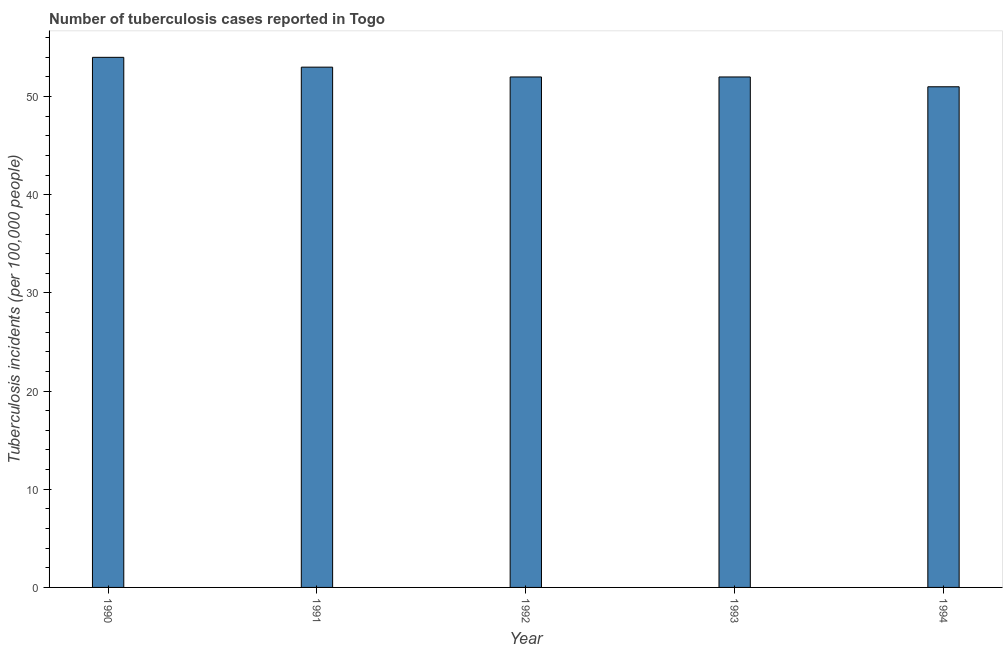Does the graph contain any zero values?
Provide a succinct answer. No. Does the graph contain grids?
Your response must be concise. No. What is the title of the graph?
Provide a succinct answer. Number of tuberculosis cases reported in Togo. What is the label or title of the Y-axis?
Your response must be concise. Tuberculosis incidents (per 100,0 people). What is the number of tuberculosis incidents in 1992?
Offer a very short reply. 52. Across all years, what is the minimum number of tuberculosis incidents?
Make the answer very short. 51. In which year was the number of tuberculosis incidents maximum?
Give a very brief answer. 1990. In which year was the number of tuberculosis incidents minimum?
Keep it short and to the point. 1994. What is the sum of the number of tuberculosis incidents?
Provide a short and direct response. 262. What is the average number of tuberculosis incidents per year?
Your answer should be compact. 52. In how many years, is the number of tuberculosis incidents greater than 22 ?
Your answer should be very brief. 5. What is the ratio of the number of tuberculosis incidents in 1990 to that in 1992?
Make the answer very short. 1.04. What is the difference between the highest and the lowest number of tuberculosis incidents?
Give a very brief answer. 3. In how many years, is the number of tuberculosis incidents greater than the average number of tuberculosis incidents taken over all years?
Give a very brief answer. 2. How many bars are there?
Offer a very short reply. 5. How many years are there in the graph?
Your answer should be very brief. 5. Are the values on the major ticks of Y-axis written in scientific E-notation?
Your answer should be very brief. No. What is the Tuberculosis incidents (per 100,000 people) in 1991?
Offer a terse response. 53. What is the difference between the Tuberculosis incidents (per 100,000 people) in 1990 and 1991?
Provide a succinct answer. 1. What is the difference between the Tuberculosis incidents (per 100,000 people) in 1990 and 1994?
Offer a very short reply. 3. What is the difference between the Tuberculosis incidents (per 100,000 people) in 1991 and 1992?
Your answer should be very brief. 1. What is the difference between the Tuberculosis incidents (per 100,000 people) in 1991 and 1993?
Your answer should be very brief. 1. What is the difference between the Tuberculosis incidents (per 100,000 people) in 1991 and 1994?
Give a very brief answer. 2. What is the difference between the Tuberculosis incidents (per 100,000 people) in 1992 and 1994?
Offer a very short reply. 1. What is the ratio of the Tuberculosis incidents (per 100,000 people) in 1990 to that in 1991?
Provide a succinct answer. 1.02. What is the ratio of the Tuberculosis incidents (per 100,000 people) in 1990 to that in 1992?
Make the answer very short. 1.04. What is the ratio of the Tuberculosis incidents (per 100,000 people) in 1990 to that in 1993?
Your answer should be compact. 1.04. What is the ratio of the Tuberculosis incidents (per 100,000 people) in 1990 to that in 1994?
Ensure brevity in your answer.  1.06. What is the ratio of the Tuberculosis incidents (per 100,000 people) in 1991 to that in 1994?
Offer a very short reply. 1.04. What is the ratio of the Tuberculosis incidents (per 100,000 people) in 1992 to that in 1994?
Keep it short and to the point. 1.02. 